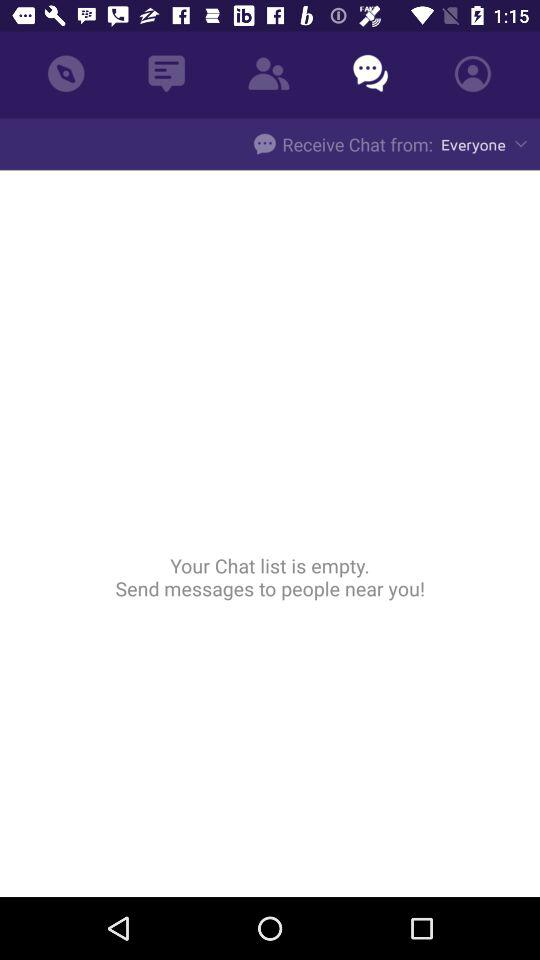Is there any message in the chat list? The chat list is empty. 